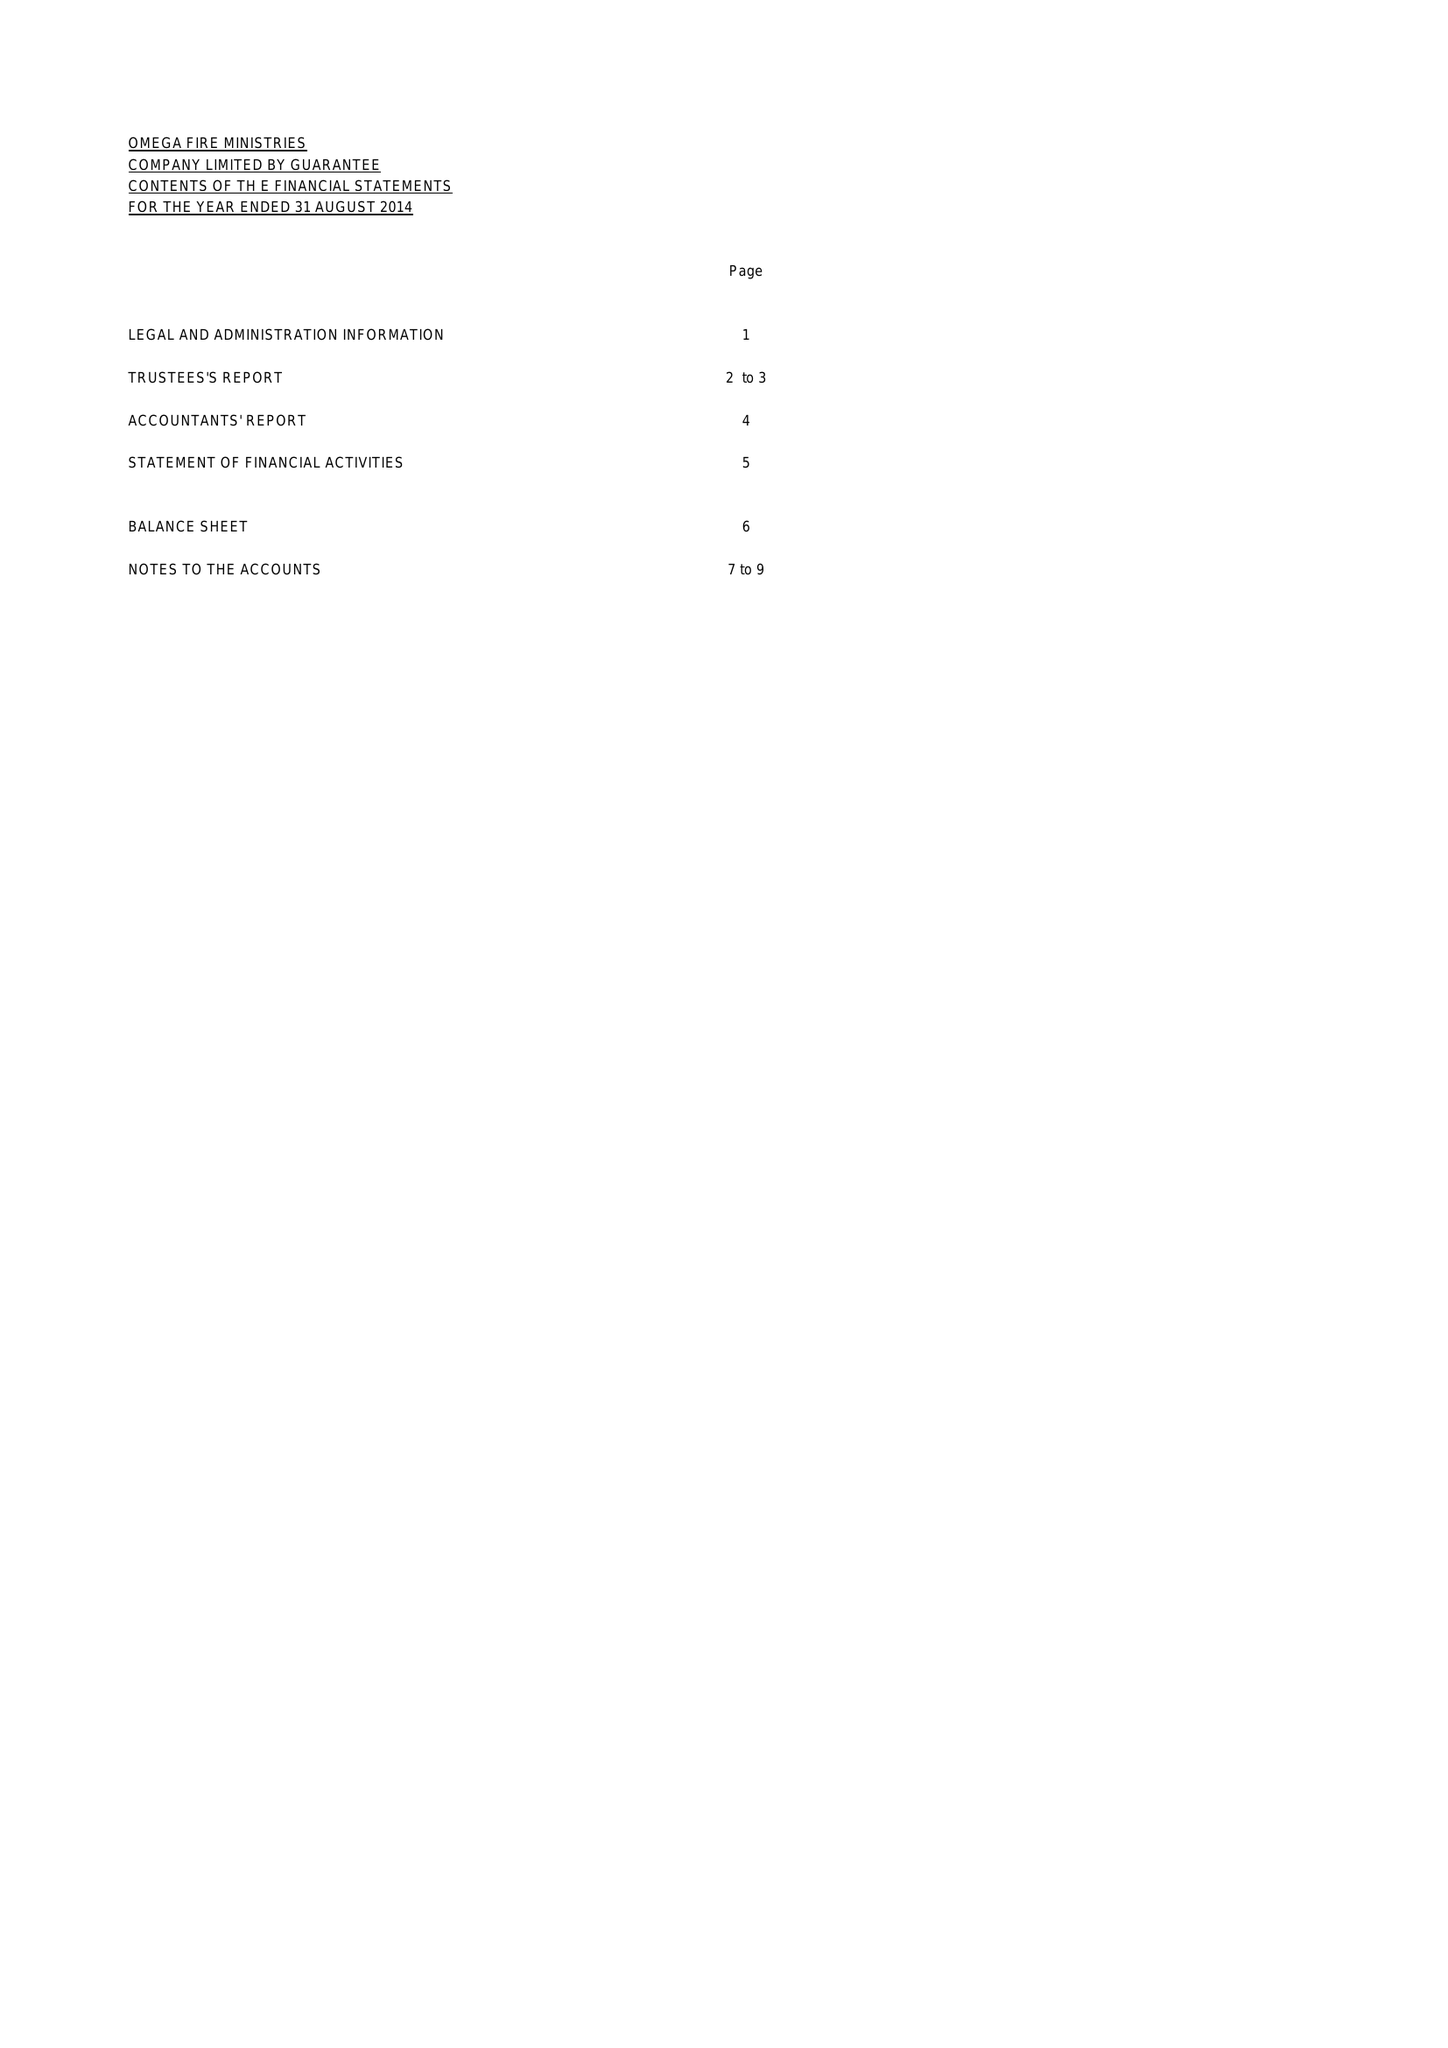What is the value for the address__street_line?
Answer the question using a single word or phrase. 33 ADOMAR ROAD 